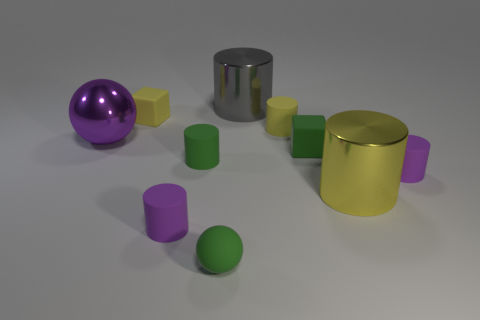The tiny matte ball that is on the left side of the tiny matte cube right of the small green rubber cylinder is what color?
Offer a terse response. Green. Is the large sphere the same color as the matte sphere?
Give a very brief answer. No. What material is the small purple cylinder that is on the right side of the small purple cylinder that is on the left side of the large yellow shiny object?
Your answer should be compact. Rubber. What material is the tiny green object that is the same shape as the purple metallic object?
Give a very brief answer. Rubber. Are there any purple shiny things in front of the small purple object to the left of the gray cylinder behind the big purple metallic ball?
Provide a short and direct response. No. What number of other things are there of the same color as the small matte sphere?
Keep it short and to the point. 2. What number of tiny rubber cubes are behind the big purple object and in front of the large purple shiny thing?
Your answer should be compact. 0. What is the shape of the purple shiny thing?
Keep it short and to the point. Sphere. How many other objects are the same material as the green cylinder?
Provide a short and direct response. 6. There is a rubber cylinder that is behind the object that is on the left side of the cube behind the big metallic ball; what is its color?
Provide a succinct answer. Yellow. 